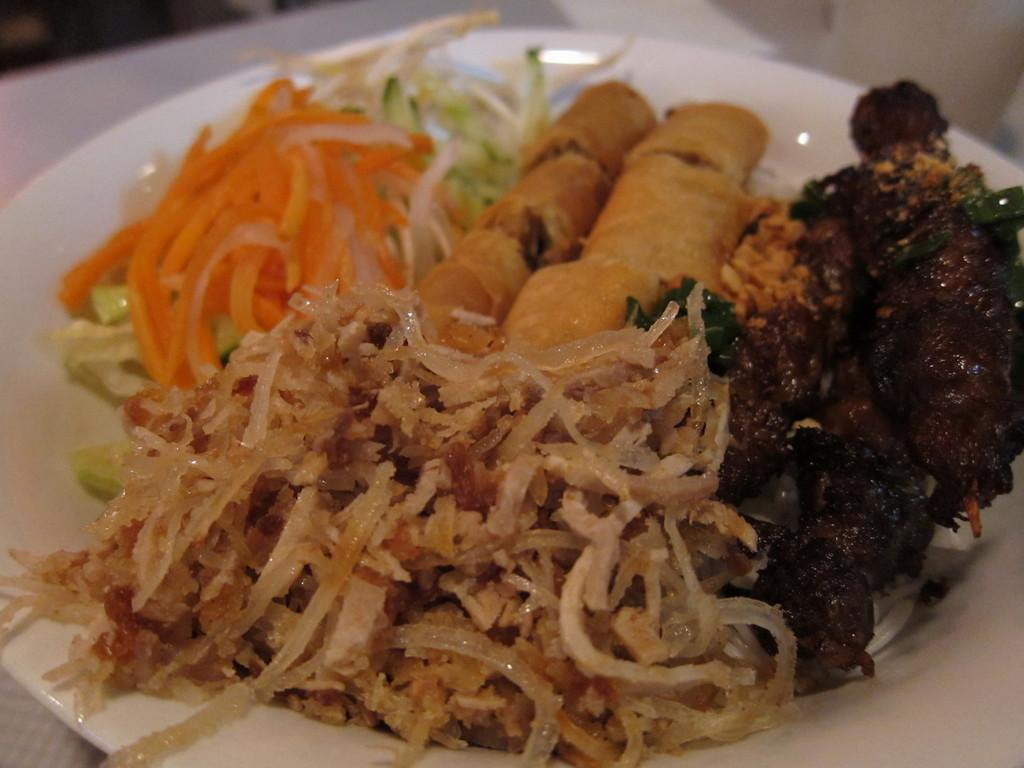What is on the plate that is visible in the image? The plate contains vegetable salads and fried food. Can you describe the types of food on the plate? The plate contains vegetable salads and fried food. What grade does the plate receive for its presentation in the image? The image does not include any grading system or criteria for evaluating the presentation of the plate. 